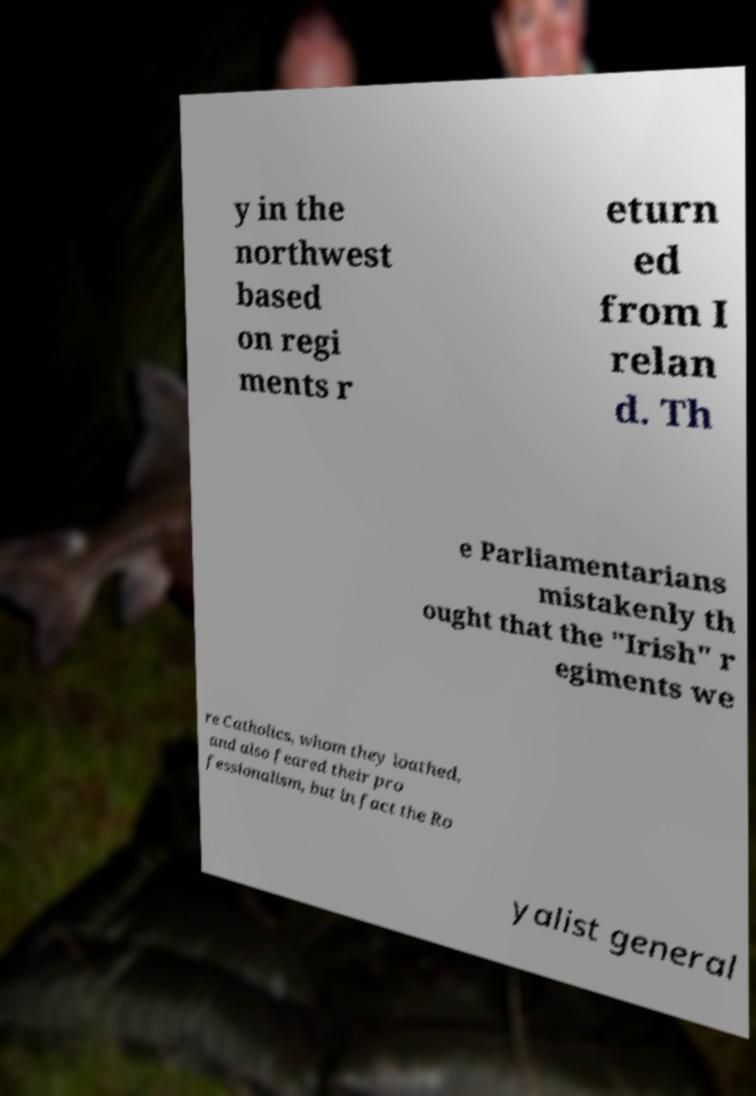What messages or text are displayed in this image? I need them in a readable, typed format. y in the northwest based on regi ments r eturn ed from I relan d. Th e Parliamentarians mistakenly th ought that the "Irish" r egiments we re Catholics, whom they loathed, and also feared their pro fessionalism, but in fact the Ro yalist general 